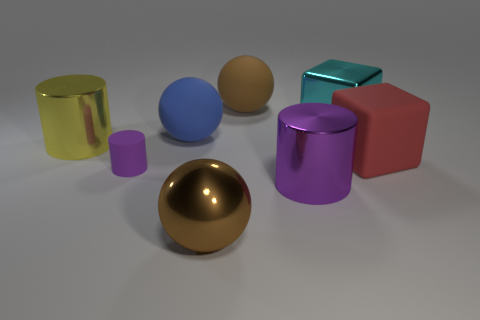Can you describe the spatial arrangement and relative sizes of the objects? Certainly, the golden sphere is notably at the forefront of the image, indicating it might be of primary importance or just spatially closest to the viewpoint. Behind it and slightly to the left is the large blue sphere, and directly to the blue sphere's right, a small lavender cylinder rests. Towards the center and right, the metallic teal cube and the red matte cube are adjacent, whereas the purple cylinder is placed further back on the left. The shiny yellow-green cylinder is set apart on the left side, creating a balanced composition that allows each object to be observed without obstruction. 